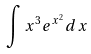<formula> <loc_0><loc_0><loc_500><loc_500>\int x ^ { 3 } e ^ { x ^ { 2 } } d x</formula> 